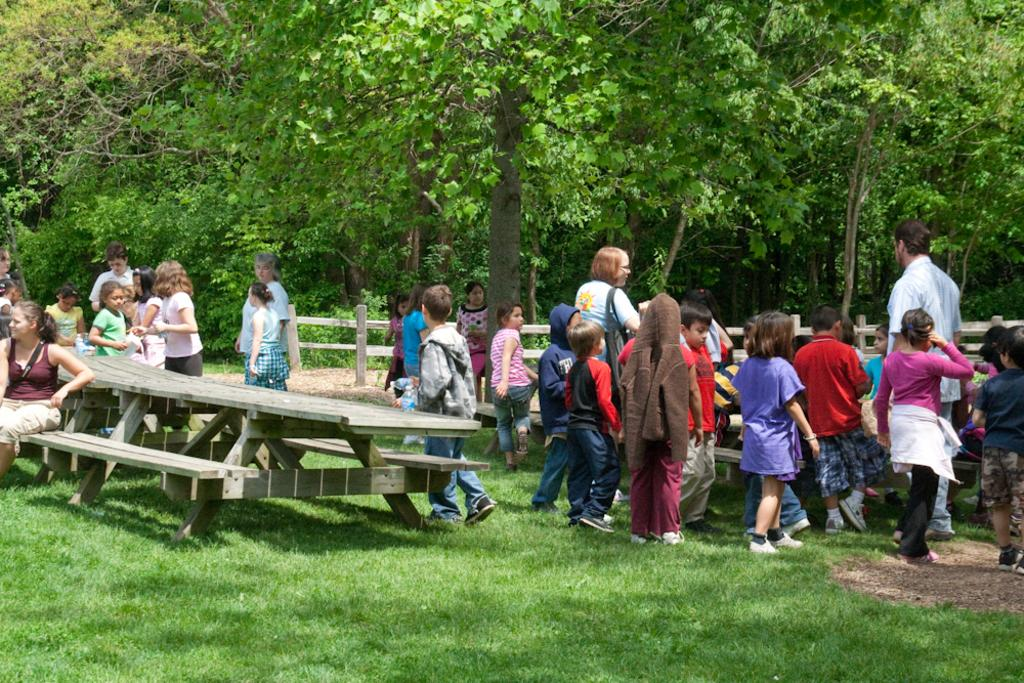How many people are present in the image? There are four people in the image: children, a man, and a woman. What objects are present in the image? There is a table and a bench in the image. What type of environment is depicted in the image? The image shows a grassy area with trees in the background. What can be seen in the background of the image? There is a railing in the background of the image. What type of belief can be seen in the image? There is no belief present in the image; it depicts people, objects, and the environment. How many birds are visible in the image? There are no birds visible in the image. 